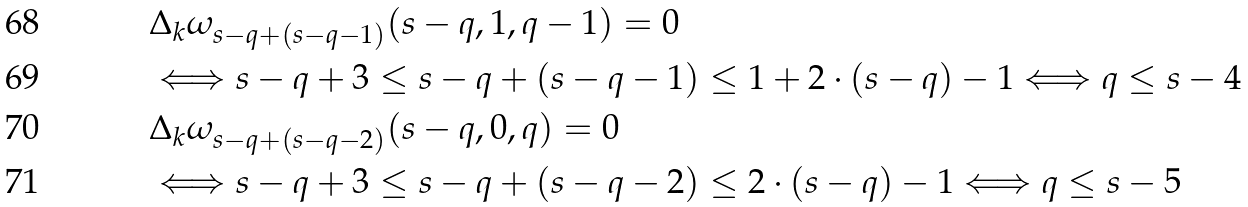<formula> <loc_0><loc_0><loc_500><loc_500>& \Delta _ { k } \omega _ { s - q + ( s - q - 1 ) } ( s - q , 1 , q - 1 ) = 0 \\ & \Longleftrightarrow s - q + 3 \leq s - q + ( s - q - 1 ) \leq 1 + 2 \cdot ( s - q ) - 1 \Longleftrightarrow q \leq s - 4 \\ & \Delta _ { k } \omega _ { s - q + ( s - q - 2 ) } ( s - q , 0 , q ) = 0 \\ & \Longleftrightarrow s - q + 3 \leq s - q + ( s - q - 2 ) \leq 2 \cdot ( s - q ) - 1 \Longleftrightarrow q \leq s - 5</formula> 